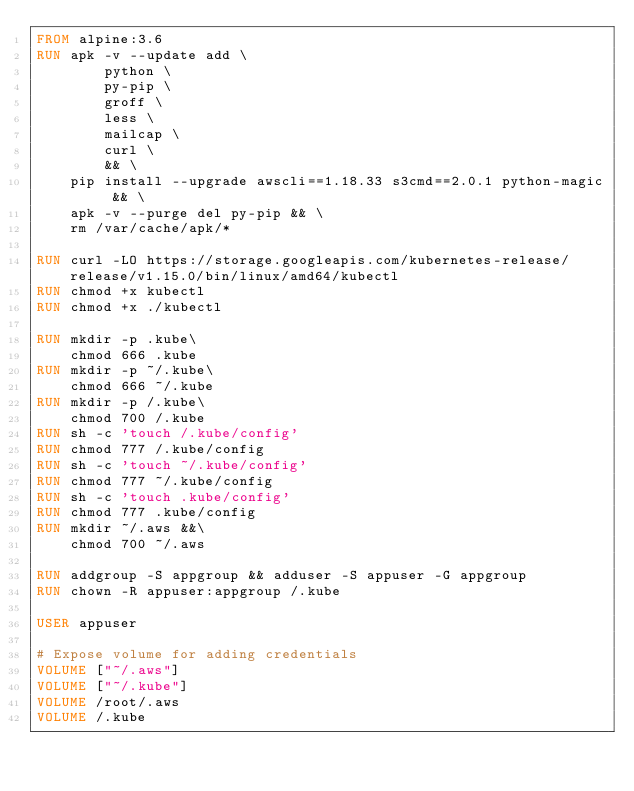Convert code to text. <code><loc_0><loc_0><loc_500><loc_500><_Dockerfile_>FROM alpine:3.6
RUN apk -v --update add \
        python \
        py-pip \
        groff \
        less \
        mailcap \
        curl \
        && \
    pip install --upgrade awscli==1.18.33 s3cmd==2.0.1 python-magic && \
    apk -v --purge del py-pip && \
    rm /var/cache/apk/*
    
RUN curl -LO https://storage.googleapis.com/kubernetes-release/release/v1.15.0/bin/linux/amd64/kubectl
RUN chmod +x kubectl
RUN chmod +x ./kubectl
    
RUN mkdir -p .kube\
    chmod 666 .kube
RUN mkdir -p ~/.kube\
    chmod 666 ~/.kube
RUN mkdir -p /.kube\
    chmod 700 /.kube
RUN sh -c 'touch /.kube/config'
RUN chmod 777 /.kube/config
RUN sh -c 'touch ~/.kube/config'
RUN chmod 777 ~/.kube/config
RUN sh -c 'touch .kube/config'
RUN chmod 777 .kube/config
RUN mkdir ~/.aws &&\
    chmod 700 ~/.aws
    
RUN addgroup -S appgroup && adduser -S appuser -G appgroup
RUN chown -R appuser:appgroup /.kube

USER appuser

# Expose volume for adding credentials
VOLUME ["~/.aws"]
VOLUME ["~/.kube"]
VOLUME /root/.aws
VOLUME /.kube

</code> 